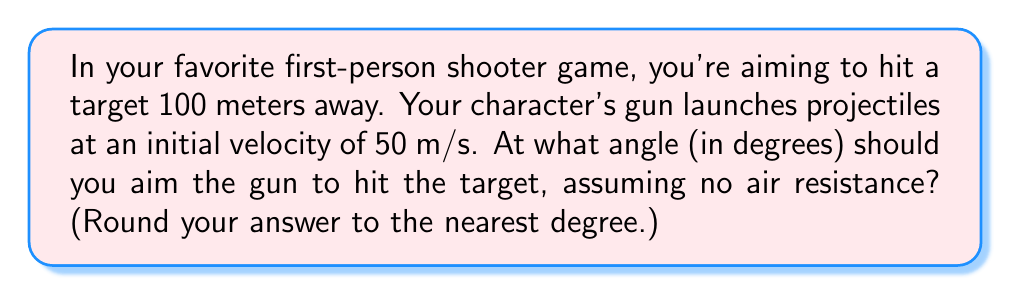Provide a solution to this math problem. To solve this problem, we'll use the equations of projectile motion and trigonometry. Let's break it down step-by-step:

1) The range equation for a projectile launched at an angle $\theta$ is:

   $$R = \frac{v_0^2 \sin(2\theta)}{g}$$

   Where $R$ is the range, $v_0$ is the initial velocity, and $g$ is the acceleration due to gravity (9.8 m/s²).

2) We know $R = 100$ m and $v_0 = 50$ m/s. Let's substitute these values:

   $$100 = \frac{50^2 \sin(2\theta)}{9.8}$$

3) Simplify:

   $$100 = \frac{2500 \sin(2\theta)}{9.8}$$

4) Multiply both sides by 9.8:

   $$980 = 2500 \sin(2\theta)$$

5) Divide both sides by 2500:

   $$0.392 = \sin(2\theta)$$

6) To solve for $\theta$, we need to take the inverse sine (arcsin) of both sides:

   $$\theta = \frac{1}{2} \arcsin(0.392)$$

7) Using a calculator or computer:

   $$\theta \approx 0.2010 \text{ radians}$$

8) Convert to degrees:

   $$\theta \approx 0.2010 \times \frac{180}{\pi} \approx 11.52°$$

9) Rounding to the nearest degree:

   $$\theta \approx 12°$$

This angle will allow the projectile to hit the target 100 meters away.
Answer: $12°$ 